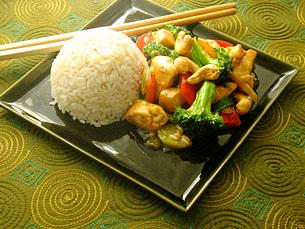What utensil will the food be eaten with? Please explain your reasoning. chopstick. There are chopsticks on the plate. 